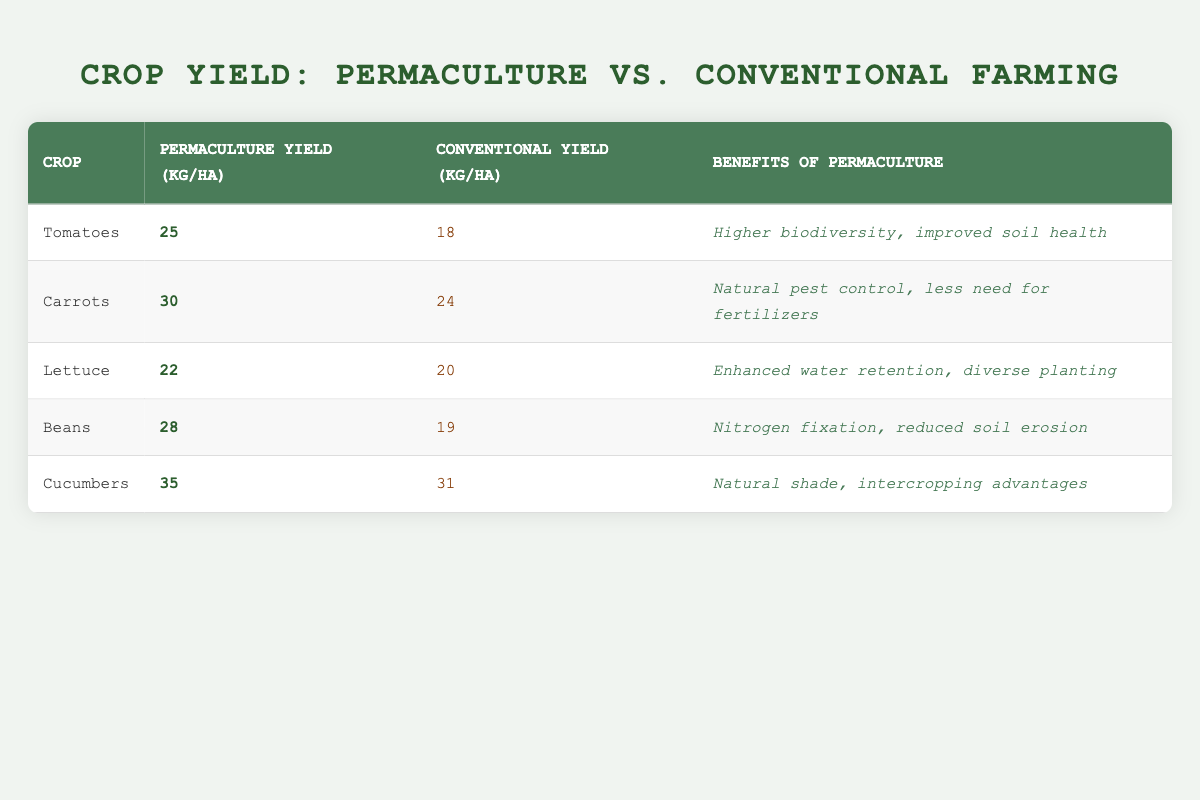What is the yield of Cucumbers in permaculture gardens? The table shows that the yield of Cucumbers in permaculture gardens is 35 kg/ha.
Answer: 35 kg/ha What crop has the highest yield in conventional farming? By comparing all conventional yields in the table, Cucumbers have the highest yield at 31 kg/ha.
Answer: 31 kg/ha What is the difference in yield for Tomatoes between permaculture and conventional farming? The table indicates that the yield for Tomatoes in permaculture is 25 kg/ha, while in conventional it is 18 kg/ha. The difference is calculated as 25 - 18 = 7 kg/ha.
Answer: 7 kg/ha True or False: Carrots yield more in permaculture than in conventional farming. The table lists the permaculture yield for Carrots as 30 kg/ha and the conventional yield as 24 kg/ha, confirming that Carrots yield more in permaculture.
Answer: True What is the average yield of all crops in permaculture gardens? To find the average, sum the permaculture yields (25 + 30 + 22 + 28 + 35 = 140) and divide by the number of crops (5). The average yield in permaculture gardens is 140 / 5 = 28 kg/ha.
Answer: 28 kg/ha How many crops yield more than 20 kg/ha in permaculture gardens? Reviewing the table, the crops that yield more than 20 kg/ha in permaculture gardens are Carrots (30), Tomatoes (25), Beans (28), and Cucumbers (35), totaling 4 crops.
Answer: 4 crops What are the benefits of growing Beans in permaculture? The table states that the benefits of growing Beans in permaculture include nitrogen fixation and reduced soil erosion.
Answer: Nitrogen fixation, reduced soil erosion True or False: Lettuce yields more in permaculture than in conventional farming. The yields listed are 22 kg/ha for permaculture and 20 kg/ha for conventional farming, confirming that Lettuce does yield more in permaculture.
Answer: True What is the total yield difference for all crops combined between permaculture and conventional farming? First, calculate the total yields: Permaculture = 25 + 30 + 22 + 28 + 35 = 140 kg/ha; Conventional = 18 + 24 + 20 + 19 + 31 = 112 kg/ha. The total yield difference is 140 - 112 = 28 kg/ha favoring permaculture.
Answer: 28 kg/ha 